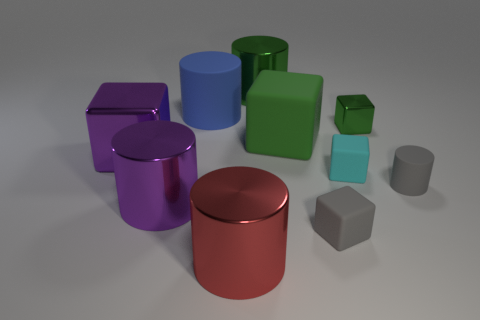Do the green cylinder and the cylinder that is right of the cyan block have the same material?
Make the answer very short. No. Are there fewer large red shiny things that are behind the large matte cylinder than big green objects that are on the left side of the big green rubber block?
Your response must be concise. Yes. Is the gray thing in front of the small gray rubber cylinder made of the same material as the large red object that is to the right of the large blue object?
Your answer should be compact. No. There is a thing that is the same color as the large metallic block; what material is it?
Make the answer very short. Metal. The object that is to the right of the tiny gray block and behind the tiny cyan object has what shape?
Your answer should be compact. Cube. What material is the large green thing that is in front of the shiny cylinder that is right of the big red object?
Provide a succinct answer. Rubber. Are there more tiny green metallic cylinders than tiny green objects?
Your answer should be very brief. No. Is the tiny cylinder the same color as the tiny shiny thing?
Your answer should be compact. No. There is a gray cylinder that is the same size as the cyan rubber cube; what material is it?
Give a very brief answer. Rubber. Does the cyan cube have the same material as the small green thing?
Give a very brief answer. No. 